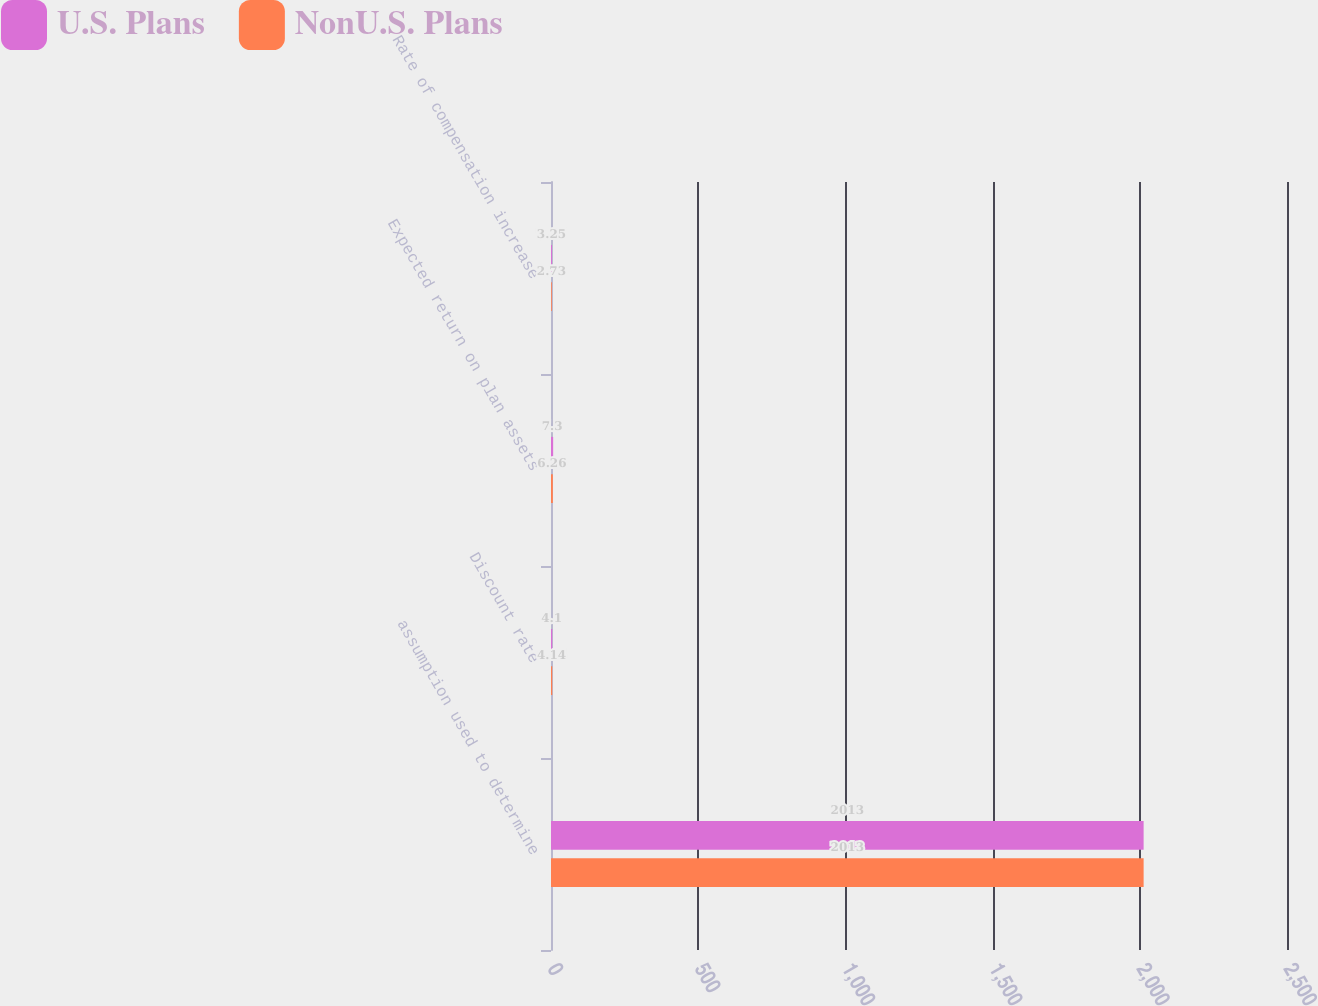Convert chart to OTSL. <chart><loc_0><loc_0><loc_500><loc_500><stacked_bar_chart><ecel><fcel>assumption used to determine<fcel>Discount rate<fcel>Expected return on plan assets<fcel>Rate of compensation increase<nl><fcel>U.S. Plans<fcel>2013<fcel>4.1<fcel>7.3<fcel>3.25<nl><fcel>NonU.S. Plans<fcel>2013<fcel>4.14<fcel>6.26<fcel>2.73<nl></chart> 